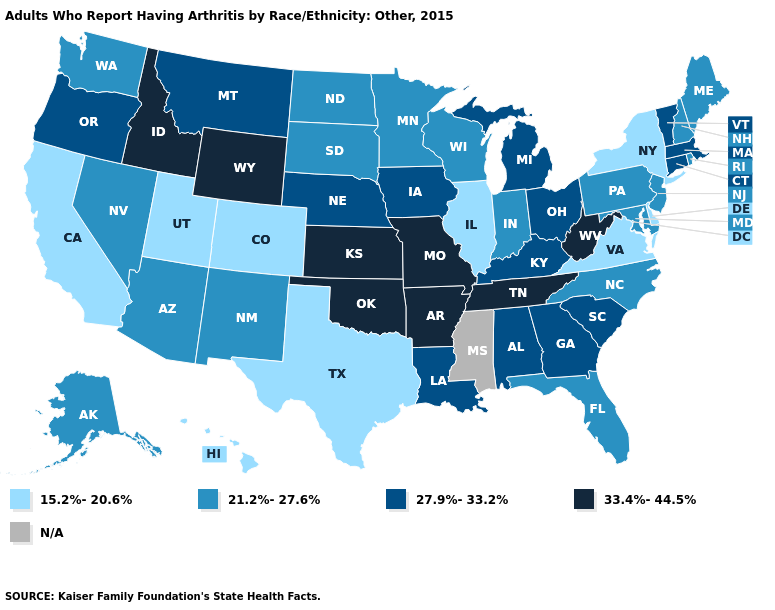Is the legend a continuous bar?
Keep it brief. No. Name the states that have a value in the range 33.4%-44.5%?
Give a very brief answer. Arkansas, Idaho, Kansas, Missouri, Oklahoma, Tennessee, West Virginia, Wyoming. What is the highest value in states that border New Hampshire?
Answer briefly. 27.9%-33.2%. Does Minnesota have the highest value in the MidWest?
Be succinct. No. Name the states that have a value in the range N/A?
Be succinct. Mississippi. What is the value of Maryland?
Short answer required. 21.2%-27.6%. What is the value of Nebraska?
Short answer required. 27.9%-33.2%. What is the lowest value in the West?
Concise answer only. 15.2%-20.6%. Does Florida have the highest value in the South?
Write a very short answer. No. What is the value of Texas?
Concise answer only. 15.2%-20.6%. What is the highest value in states that border Maine?
Quick response, please. 21.2%-27.6%. Which states have the lowest value in the USA?
Answer briefly. California, Colorado, Delaware, Hawaii, Illinois, New York, Texas, Utah, Virginia. 